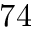Convert formula to latex. <formula><loc_0><loc_0><loc_500><loc_500>7 4</formula> 